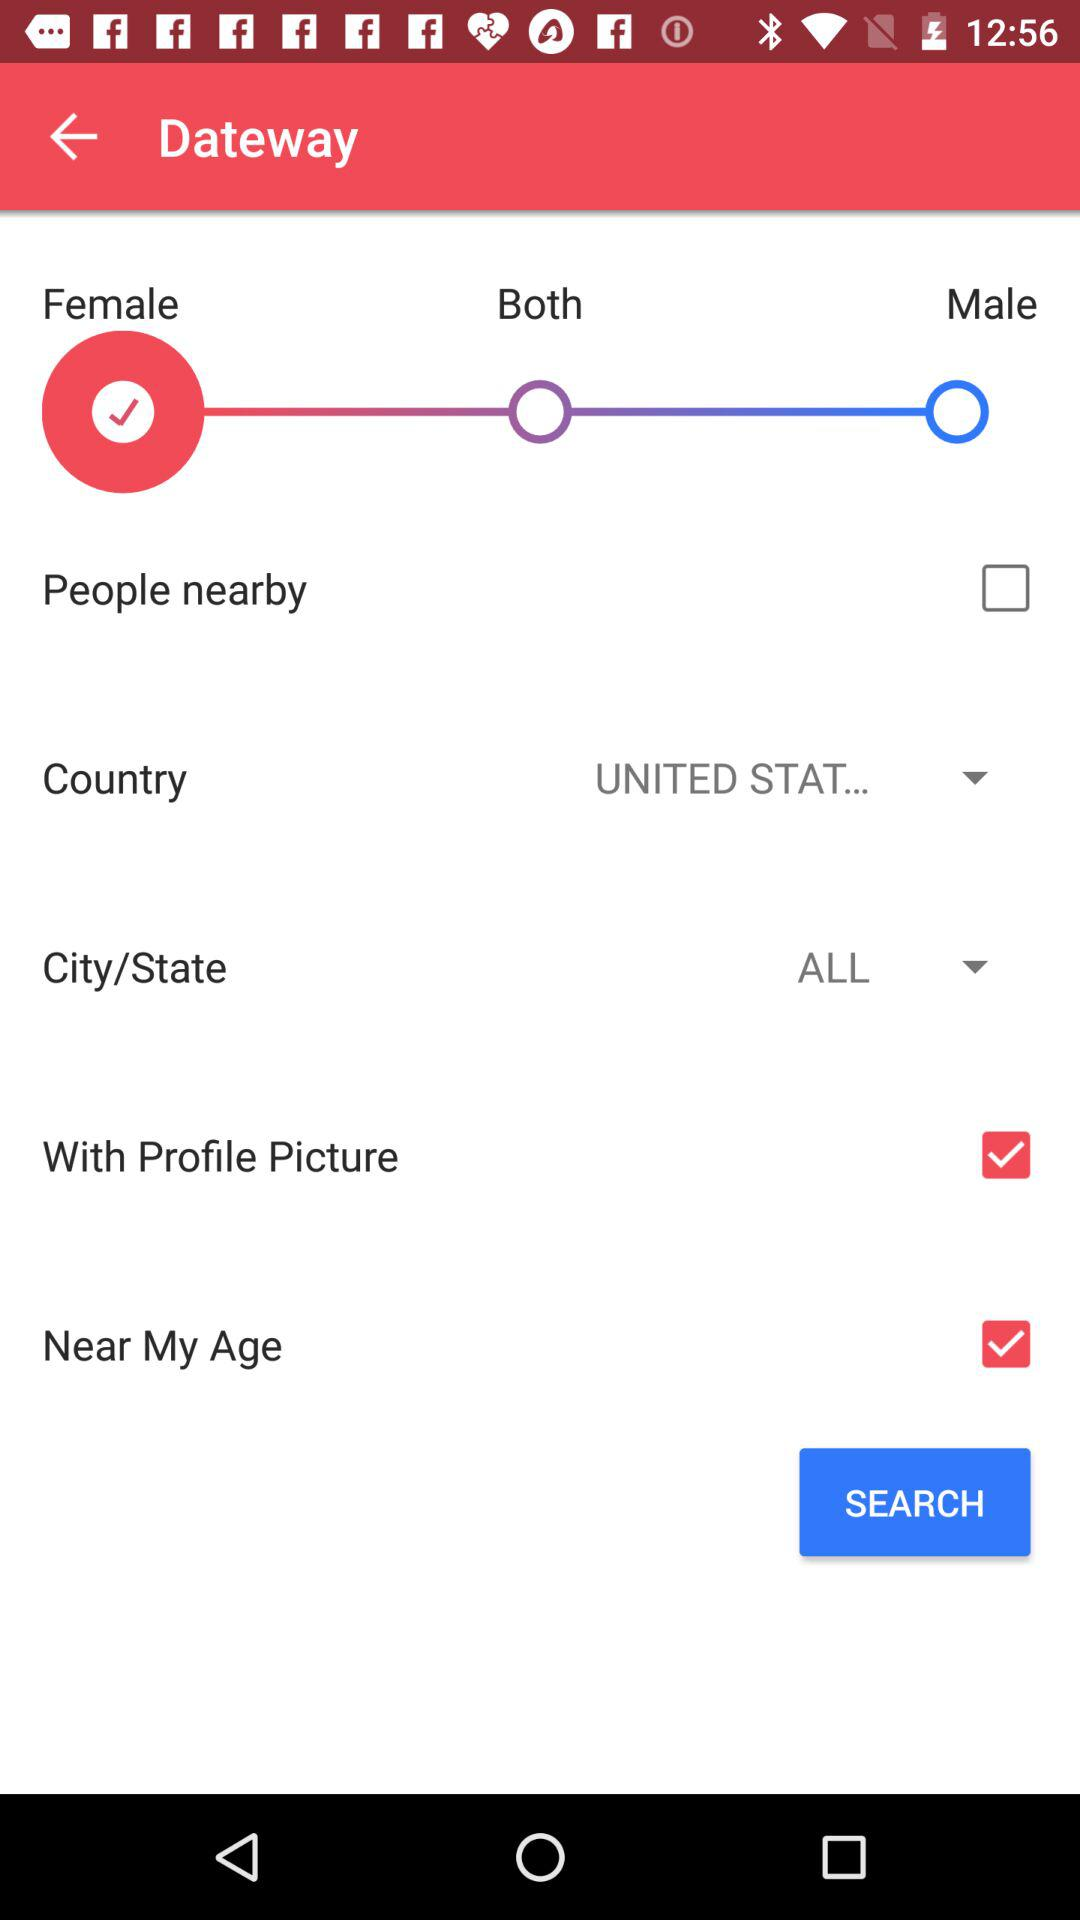What is the selected country? The selected country is "UNITED STAT...". 